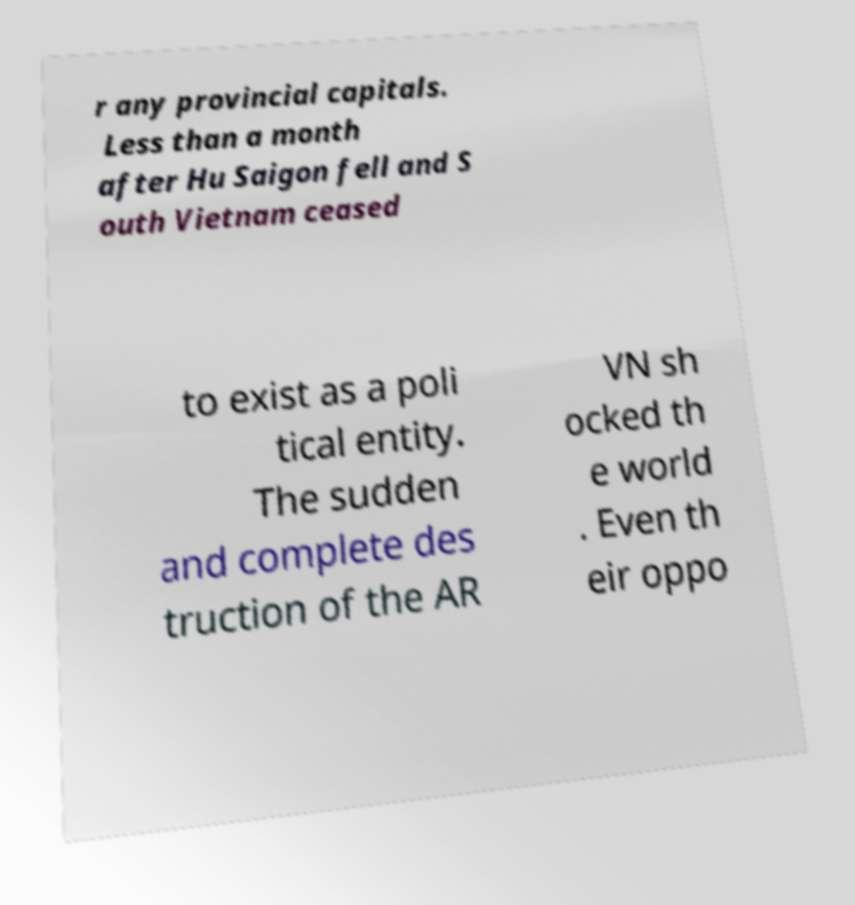Can you read and provide the text displayed in the image?This photo seems to have some interesting text. Can you extract and type it out for me? r any provincial capitals. Less than a month after Hu Saigon fell and S outh Vietnam ceased to exist as a poli tical entity. The sudden and complete des truction of the AR VN sh ocked th e world . Even th eir oppo 